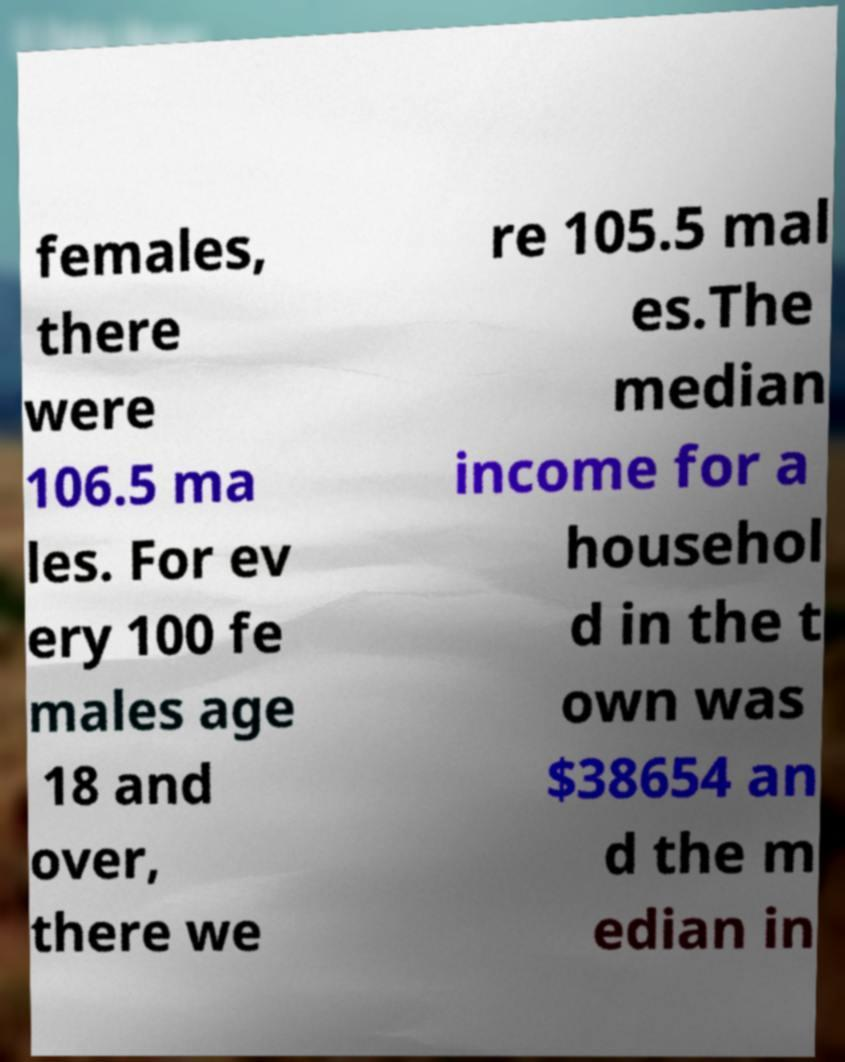Please identify and transcribe the text found in this image. females, there were 106.5 ma les. For ev ery 100 fe males age 18 and over, there we re 105.5 mal es.The median income for a househol d in the t own was $38654 an d the m edian in 